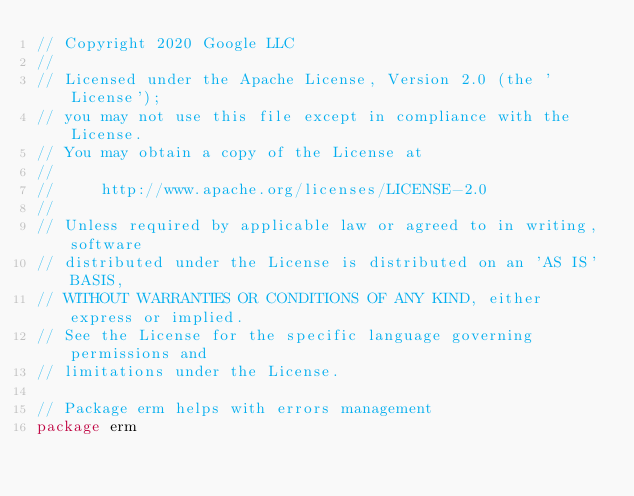Convert code to text. <code><loc_0><loc_0><loc_500><loc_500><_Go_>// Copyright 2020 Google LLC
//
// Licensed under the Apache License, Version 2.0 (the 'License');
// you may not use this file except in compliance with the License.
// You may obtain a copy of the License at
//
//     http://www.apache.org/licenses/LICENSE-2.0
//
// Unless required by applicable law or agreed to in writing, software
// distributed under the License is distributed on an 'AS IS' BASIS,
// WITHOUT WARRANTIES OR CONDITIONS OF ANY KIND, either express or implied.
// See the License for the specific language governing permissions and
// limitations under the License.

// Package erm helps with errors management
package erm
</code> 